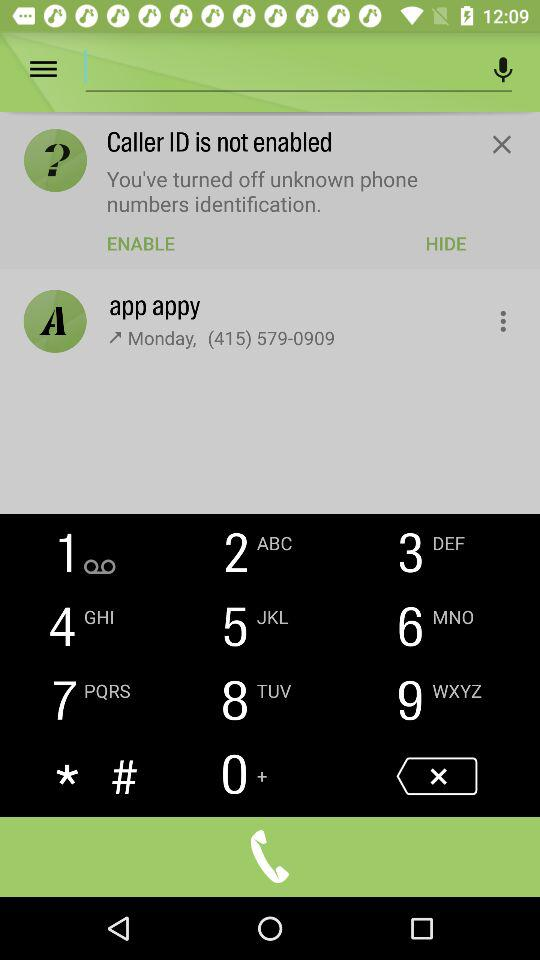What is the contact number of App Appy? The contact number is (415) 579-0909. 